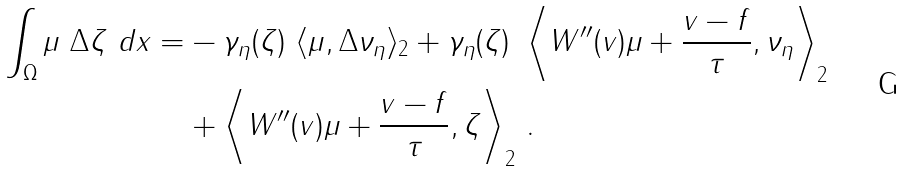<formula> <loc_0><loc_0><loc_500><loc_500>\int _ { \Omega } \mu \ \Delta \zeta \ d x = & - \gamma _ { \eta } ( \zeta ) \ \langle \mu , \Delta \nu _ { \eta } \rangle _ { 2 } + \gamma _ { \eta } ( \zeta ) \ \left \langle W ^ { \prime \prime } ( v ) \mu + \frac { v - f } { \tau } , \nu _ { \eta } \right \rangle _ { 2 } \\ & + \left \langle W ^ { \prime \prime } ( v ) \mu + \frac { v - f } { \tau } , \zeta \right \rangle _ { 2 } \, .</formula> 